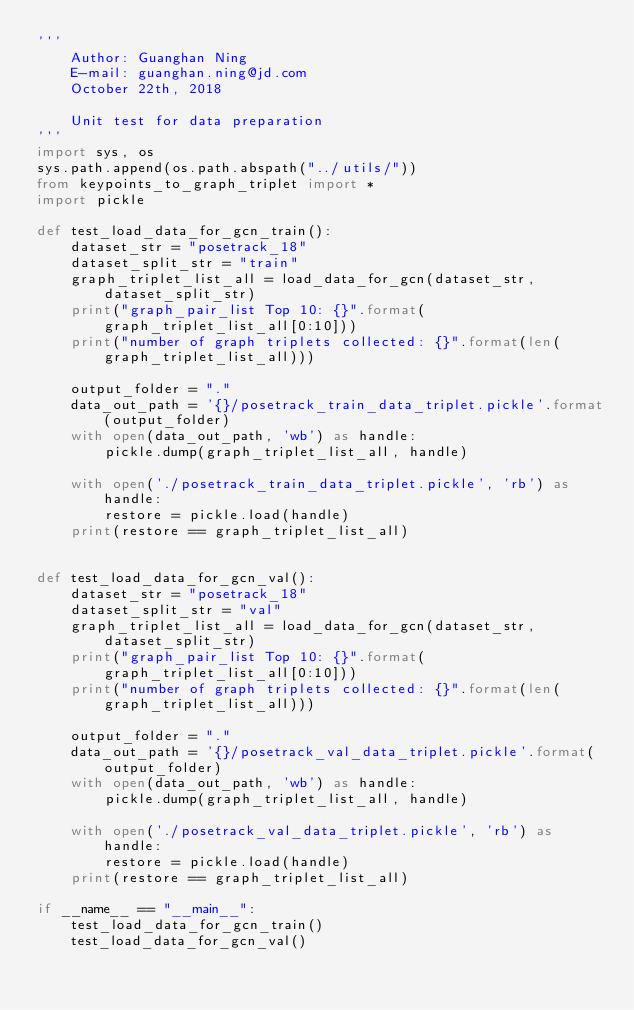Convert code to text. <code><loc_0><loc_0><loc_500><loc_500><_Python_>'''
    Author: Guanghan Ning
    E-mail: guanghan.ning@jd.com
    October 22th, 2018

    Unit test for data preparation
'''
import sys, os
sys.path.append(os.path.abspath("../utils/"))
from keypoints_to_graph_triplet import *
import pickle

def test_load_data_for_gcn_train():
    dataset_str = "posetrack_18"
    dataset_split_str = "train"
    graph_triplet_list_all = load_data_for_gcn(dataset_str, dataset_split_str)
    print("graph_pair_list Top 10: {}".format(graph_triplet_list_all[0:10]))
    print("number of graph triplets collected: {}".format(len(graph_triplet_list_all)))

    output_folder = "."
    data_out_path = '{}/posetrack_train_data_triplet.pickle'.format(output_folder)
    with open(data_out_path, 'wb') as handle:
        pickle.dump(graph_triplet_list_all, handle)

    with open('./posetrack_train_data_triplet.pickle', 'rb') as handle:
        restore = pickle.load(handle)
    print(restore == graph_triplet_list_all)


def test_load_data_for_gcn_val():
    dataset_str = "posetrack_18"
    dataset_split_str = "val"
    graph_triplet_list_all = load_data_for_gcn(dataset_str, dataset_split_str)
    print("graph_pair_list Top 10: {}".format(graph_triplet_list_all[0:10]))
    print("number of graph triplets collected: {}".format(len(graph_triplet_list_all)))

    output_folder = "."
    data_out_path = '{}/posetrack_val_data_triplet.pickle'.format(output_folder)
    with open(data_out_path, 'wb') as handle:
        pickle.dump(graph_triplet_list_all, handle)

    with open('./posetrack_val_data_triplet.pickle', 'rb') as handle:
        restore = pickle.load(handle)
    print(restore == graph_triplet_list_all)

if __name__ == "__main__":
    test_load_data_for_gcn_train()
    test_load_data_for_gcn_val()
</code> 